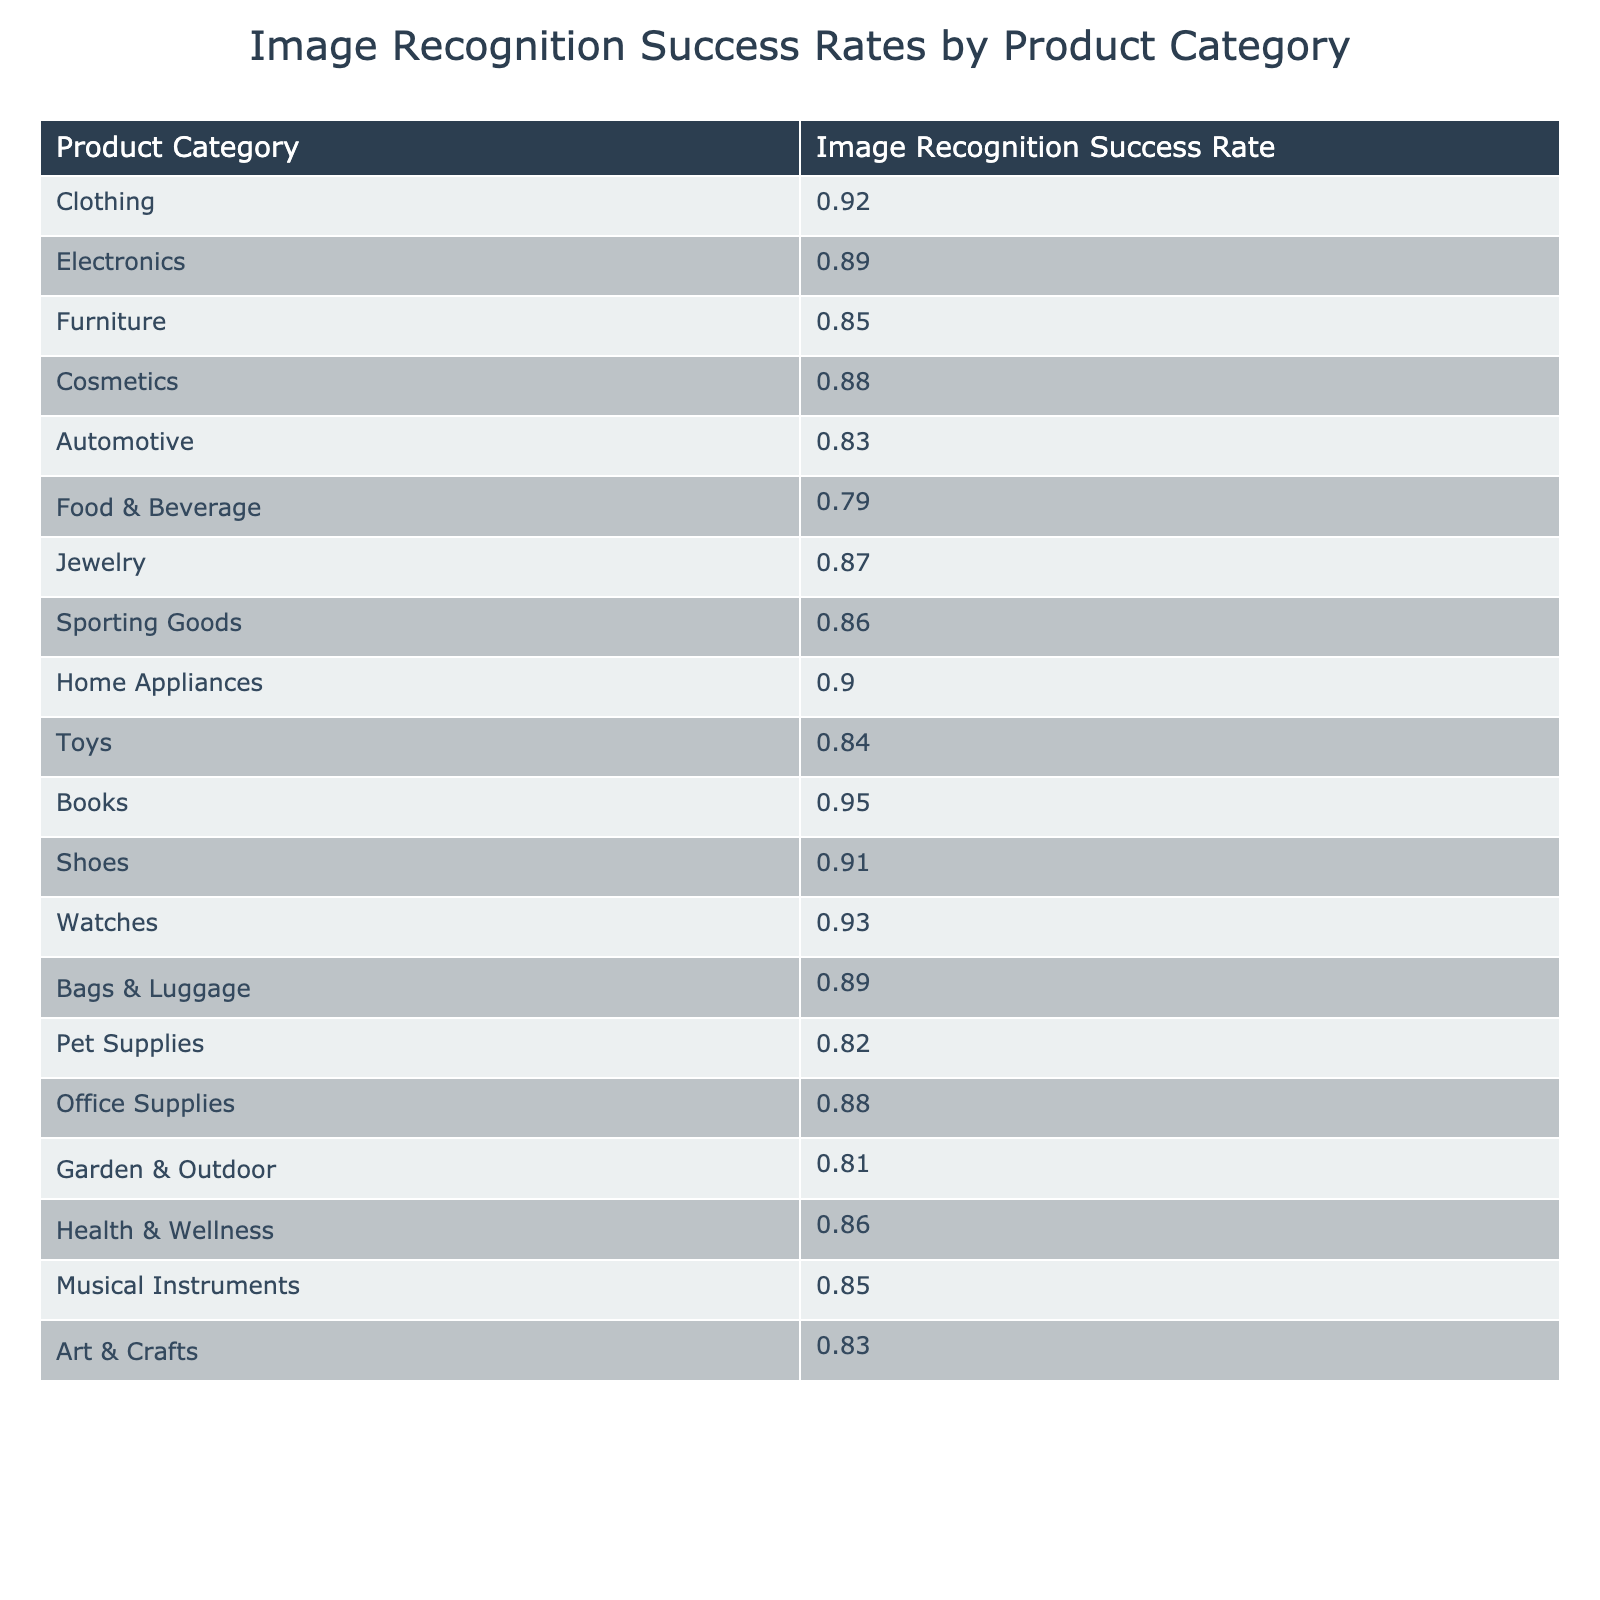What is the image recognition success rate for the Clothing category? The table indicates the success rate for Clothing, which is listed directly under the Clothing product category. The specified value is 0.92.
Answer: 0.92 Which product category has the highest image recognition success rate? By reviewing the data, the highest success rate can be identified by comparing all product categories. The Clothing category shows the highest rate of 0.92.
Answer: Clothing Is the image recognition success rate for Toys greater than that for Automotive? The success rate for Toys is 0.84 while for Automotive, it is 0.83. Since 0.84 is greater than 0.83, the statement is true.
Answer: Yes What are the success rates for Electronics and Furniture? In the table, the success rate for Electronics is 0.89, and for Furniture, it is 0.85. This can be directly retrieved from the respective rows in the table.
Answer: Electronics: 0.89, Furniture: 0.85 What is the average image recognition success rate for the top 3 categories? The top 3 categories by success rate are Clothing (0.92), Watches (0.93), and Books (0.95). To find the average, we sum these rates (0.92 + 0.93 + 0.95 = 2.80) and divide by 3, resulting in an average of approximately 0.9333.
Answer: 0.9333 Which category has a success rate lower than 0.85? By scanning the table, categories with success rates below 0.85 include Food & Beverage (0.79), Automotive (0.83), and Garden & Outdoor (0.81).
Answer: Food & Beverage, Automotive, Garden & Outdoor What category ranks second in the image recognition success rate? The table must be ordered by success rates. The first ranked is Clothing (0.92), and the second is Watches (0.93). Thus, if sorted in descending order, Toys comes next, but Watches is the second overall in value.
Answer: Watches How many categories have a success rate above 0.88? Reviewing the table, we list categories exceeding this threshold: Clothing (0.92), Watches (0.93), Books (0.95), and Home Appliances (0.90). Counting these gives us four categories.
Answer: 4 Is the average success rate for Health & Wellness and Sporting Goods greater than 0.85? The success rates are 0.86 for Health & Wellness and 0.86 for Sporting Goods. Their average is (0.86 + 0.86)/2 = 0.86, which is greater than 0.85.
Answer: Yes What is the difference in success rate between the highest and lowest performing categories? The highest performing category is Books with a success rate of 0.95, and the lowest is Food & Beverage with 0.79. The difference is calculated as 0.95 - 0.79 = 0.16.
Answer: 0.16 